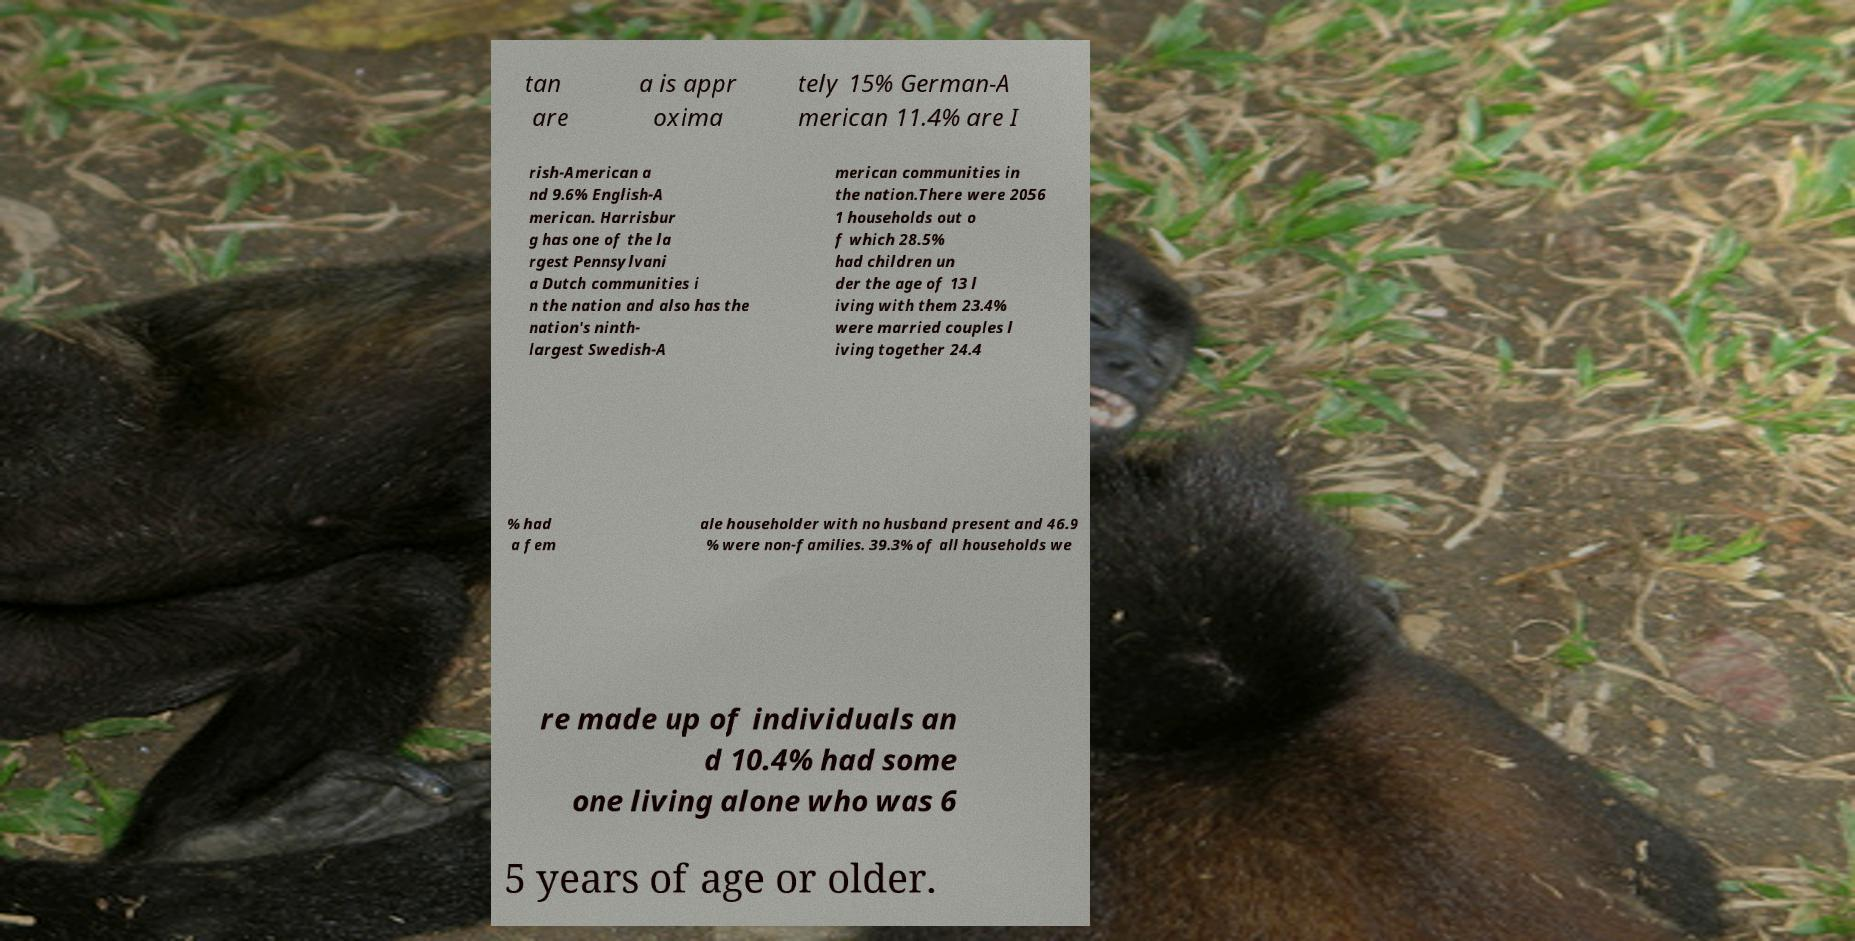What messages or text are displayed in this image? I need them in a readable, typed format. tan are a is appr oxima tely 15% German-A merican 11.4% are I rish-American a nd 9.6% English-A merican. Harrisbur g has one of the la rgest Pennsylvani a Dutch communities i n the nation and also has the nation's ninth- largest Swedish-A merican communities in the nation.There were 2056 1 households out o f which 28.5% had children un der the age of 13 l iving with them 23.4% were married couples l iving together 24.4 % had a fem ale householder with no husband present and 46.9 % were non-families. 39.3% of all households we re made up of individuals an d 10.4% had some one living alone who was 6 5 years of age or older. 